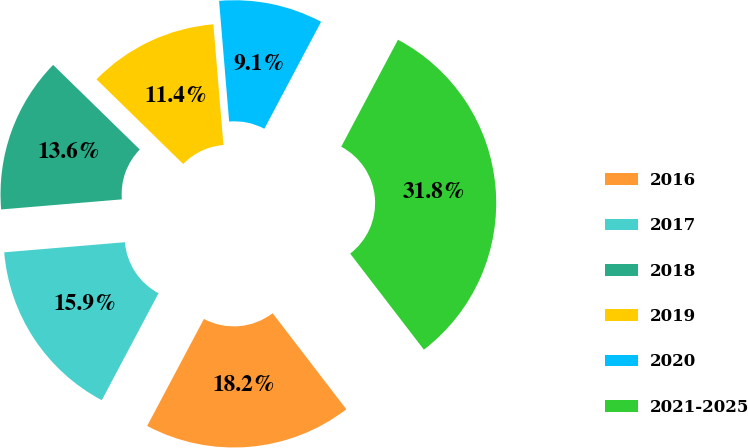Convert chart. <chart><loc_0><loc_0><loc_500><loc_500><pie_chart><fcel>2016<fcel>2017<fcel>2018<fcel>2019<fcel>2020<fcel>2021-2025<nl><fcel>18.18%<fcel>15.91%<fcel>13.64%<fcel>11.36%<fcel>9.09%<fcel>31.82%<nl></chart> 